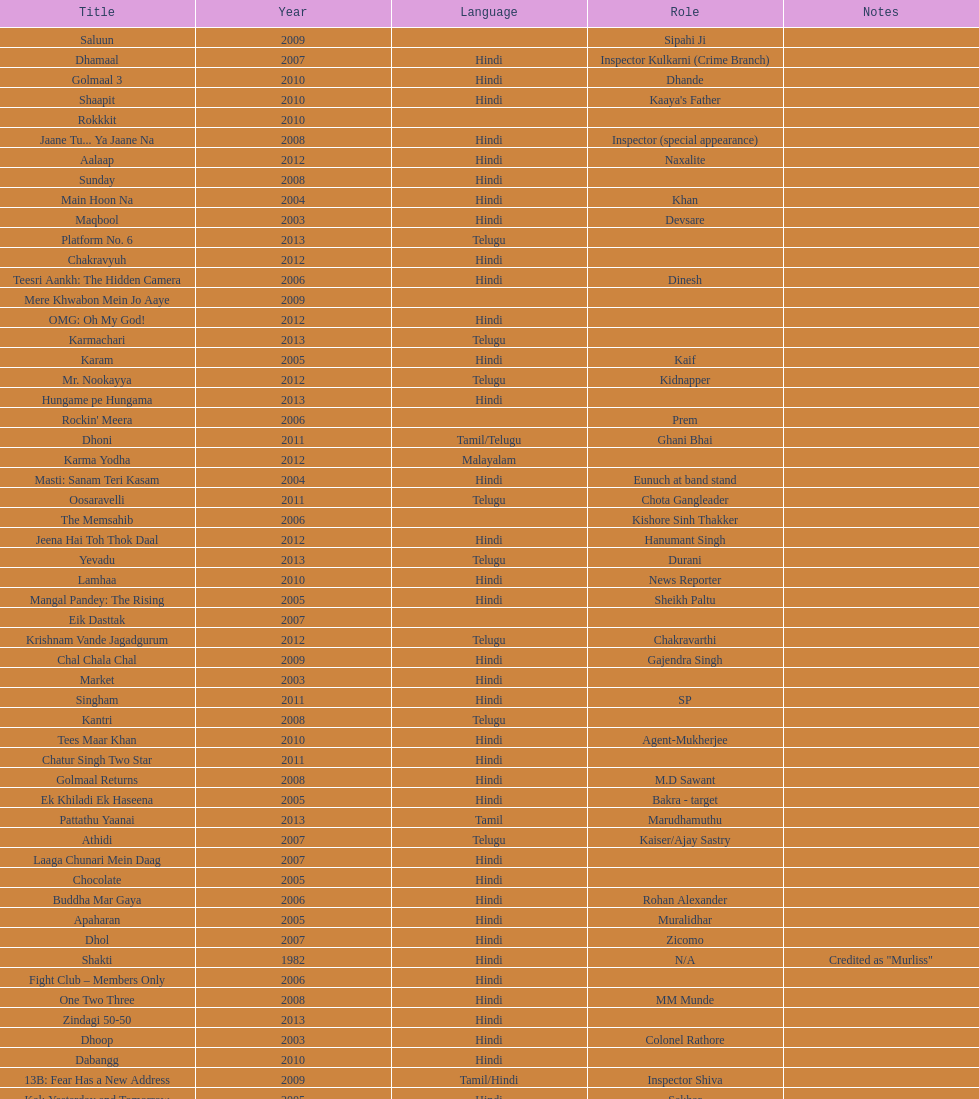What was the last malayalam film this actor starred in? Karma Yodha. Parse the full table. {'header': ['Title', 'Year', 'Language', 'Role', 'Notes'], 'rows': [['Saluun', '2009', '', 'Sipahi Ji', ''], ['Dhamaal', '2007', 'Hindi', 'Inspector Kulkarni (Crime Branch)', ''], ['Golmaal 3', '2010', 'Hindi', 'Dhande', ''], ['Shaapit', '2010', 'Hindi', "Kaaya's Father", ''], ['Rokkkit', '2010', '', '', ''], ['Jaane Tu... Ya Jaane Na', '2008', 'Hindi', 'Inspector (special appearance)', ''], ['Aalaap', '2012', 'Hindi', 'Naxalite', ''], ['Sunday', '2008', 'Hindi', '', ''], ['Main Hoon Na', '2004', 'Hindi', 'Khan', ''], ['Maqbool', '2003', 'Hindi', 'Devsare', ''], ['Platform No. 6', '2013', 'Telugu', '', ''], ['Chakravyuh', '2012', 'Hindi', '', ''], ['Teesri Aankh: The Hidden Camera', '2006', 'Hindi', 'Dinesh', ''], ['Mere Khwabon Mein Jo Aaye', '2009', '', '', ''], ['OMG: Oh My God!', '2012', 'Hindi', '', ''], ['Karmachari', '2013', 'Telugu', '', ''], ['Karam', '2005', 'Hindi', 'Kaif', ''], ['Mr. Nookayya', '2012', 'Telugu', 'Kidnapper', ''], ['Hungame pe Hungama', '2013', 'Hindi', '', ''], ["Rockin' Meera", '2006', '', 'Prem', ''], ['Dhoni', '2011', 'Tamil/Telugu', 'Ghani Bhai', ''], ['Karma Yodha', '2012', 'Malayalam', '', ''], ['Masti: Sanam Teri Kasam', '2004', 'Hindi', 'Eunuch at band stand', ''], ['Oosaravelli', '2011', 'Telugu', 'Chota Gangleader', ''], ['The Memsahib', '2006', '', 'Kishore Sinh Thakker', ''], ['Jeena Hai Toh Thok Daal', '2012', 'Hindi', 'Hanumant Singh', ''], ['Yevadu', '2013', 'Telugu', 'Durani', ''], ['Lamhaa', '2010', 'Hindi', 'News Reporter', ''], ['Mangal Pandey: The Rising', '2005', 'Hindi', 'Sheikh Paltu', ''], ['Eik Dasttak', '2007', '', '', ''], ['Krishnam Vande Jagadgurum', '2012', 'Telugu', 'Chakravarthi', ''], ['Chal Chala Chal', '2009', 'Hindi', 'Gajendra Singh', ''], ['Market', '2003', 'Hindi', '', ''], ['Singham', '2011', 'Hindi', 'SP', ''], ['Kantri', '2008', 'Telugu', '', ''], ['Tees Maar Khan', '2010', 'Hindi', 'Agent-Mukherjee', ''], ['Chatur Singh Two Star', '2011', 'Hindi', '', ''], ['Golmaal Returns', '2008', 'Hindi', 'M.D Sawant', ''], ['Ek Khiladi Ek Haseena', '2005', 'Hindi', 'Bakra - target', ''], ['Pattathu Yaanai', '2013', 'Tamil', 'Marudhamuthu', ''], ['Athidi', '2007', 'Telugu', 'Kaiser/Ajay Sastry', ''], ['Laaga Chunari Mein Daag', '2007', 'Hindi', '', ''], ['Chocolate', '2005', 'Hindi', '', ''], ['Buddha Mar Gaya', '2006', 'Hindi', 'Rohan Alexander', ''], ['Apaharan', '2005', 'Hindi', 'Muralidhar', ''], ['Dhol', '2007', 'Hindi', 'Zicomo', ''], ['Shakti', '1982', 'Hindi', 'N/A', 'Credited as "Murliss"'], ['Fight Club – Members Only', '2006', 'Hindi', '', ''], ['One Two Three', '2008', 'Hindi', 'MM Munde', ''], ['Zindagi 50-50', '2013', 'Hindi', '', ''], ['Dhoop', '2003', 'Hindi', 'Colonel Rathore', ''], ['Dabangg', '2010', 'Hindi', '', ''], ['13B: Fear Has a New Address', '2009', 'Tamil/Hindi', 'Inspector Shiva', ''], ['Kal: Yesterday and Tomorrow', '2005', 'Hindi', 'Sekhar', ''], ['Black Friday', '2004', 'Hindi', '', ''], ['Dil Vil Pyar Vyar', '2002', 'Hindi', 'N/A', ''], ['Choron Ki Baraat', '2012', 'Hindi', 'Tejeshwar Singh', '']]} 